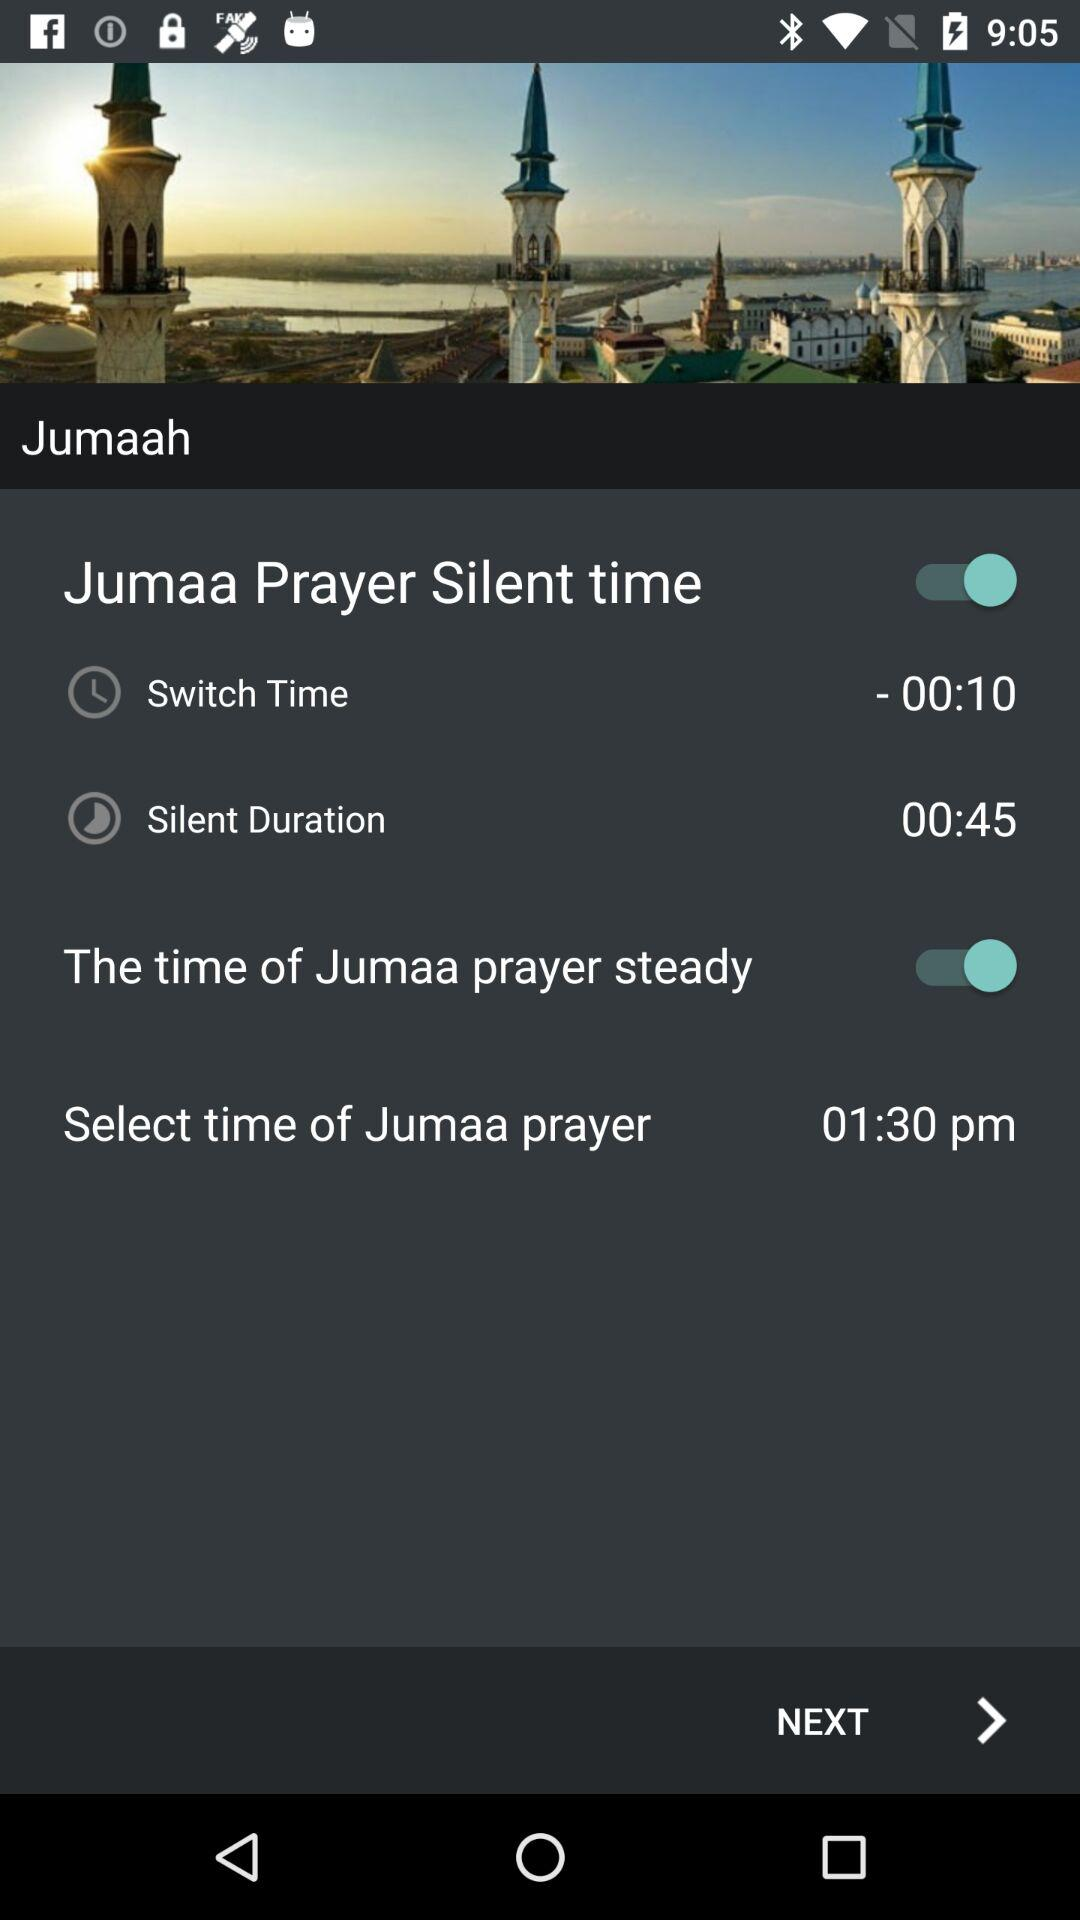What is the time of Jumaa prayer? The time of Jumaa prayer is 01:30 p.m. 